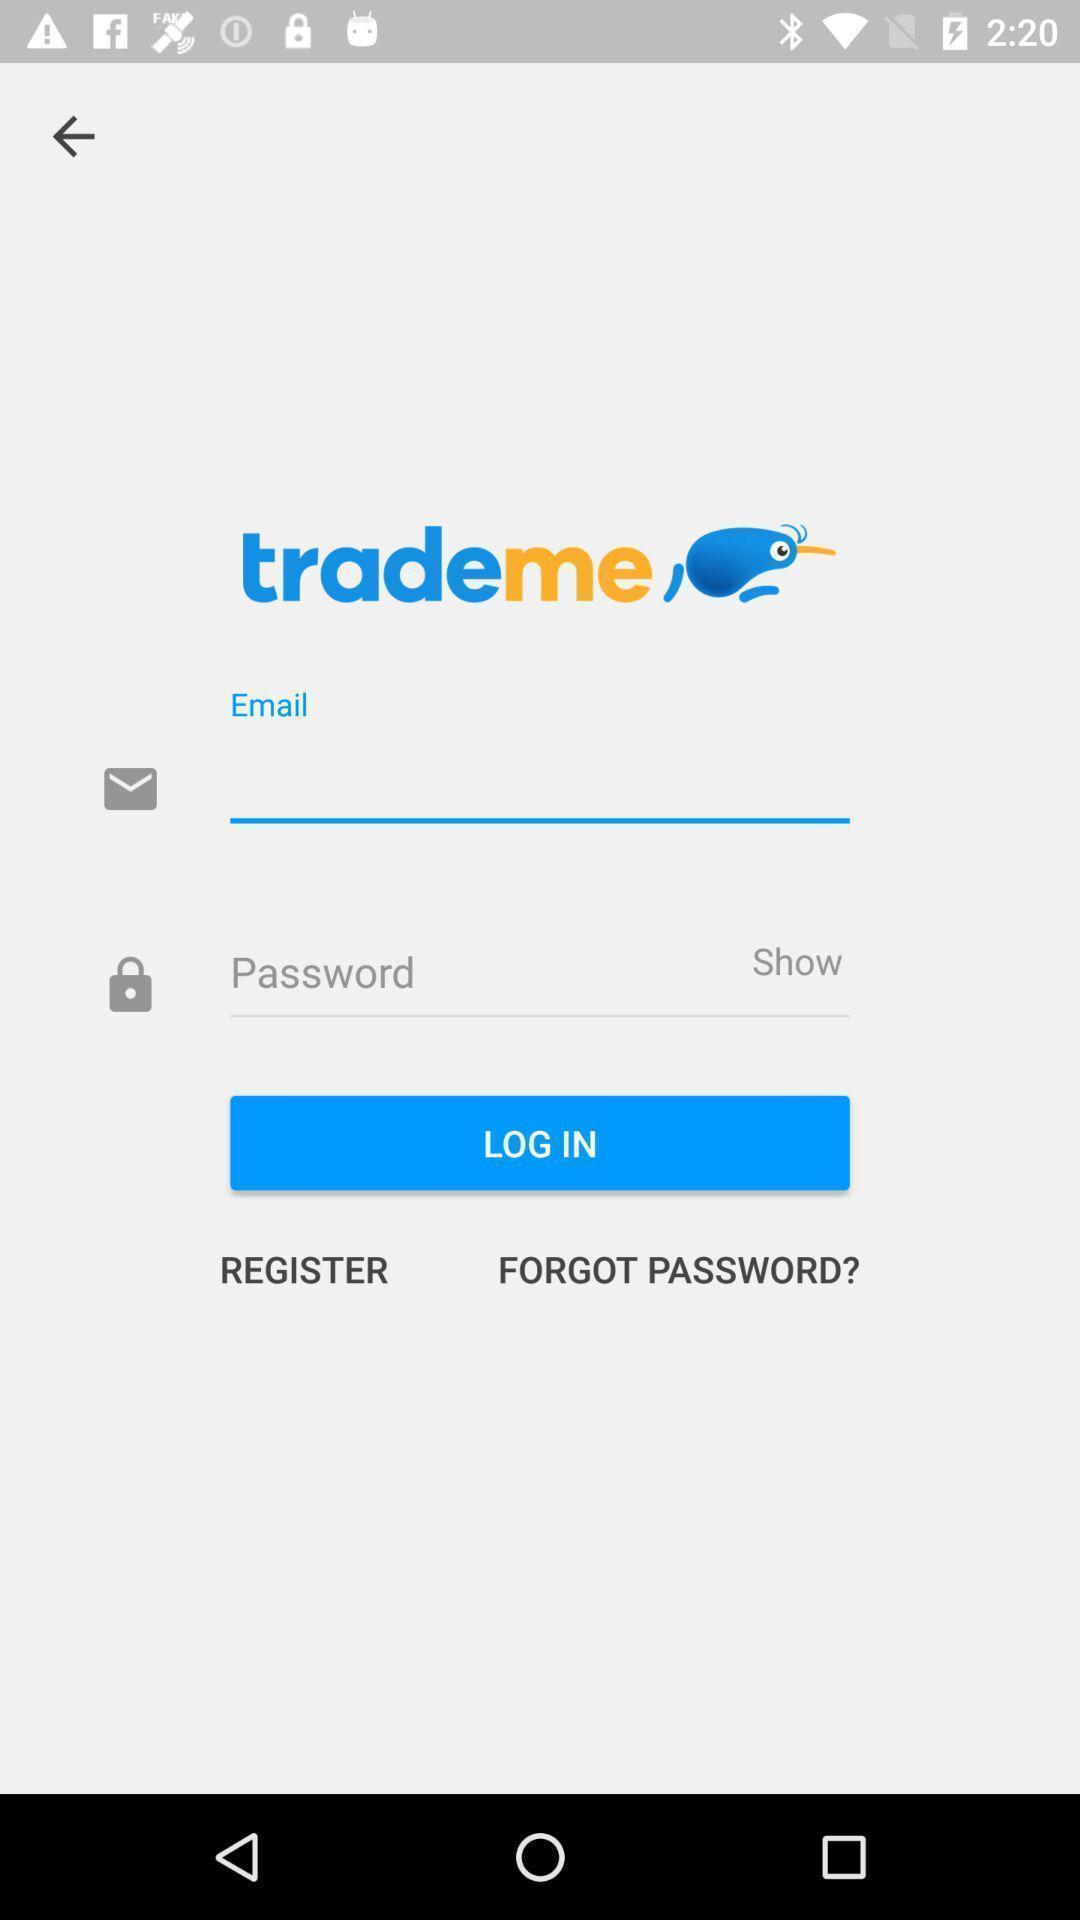Provide a detailed account of this screenshot. Welcome to the login page. 